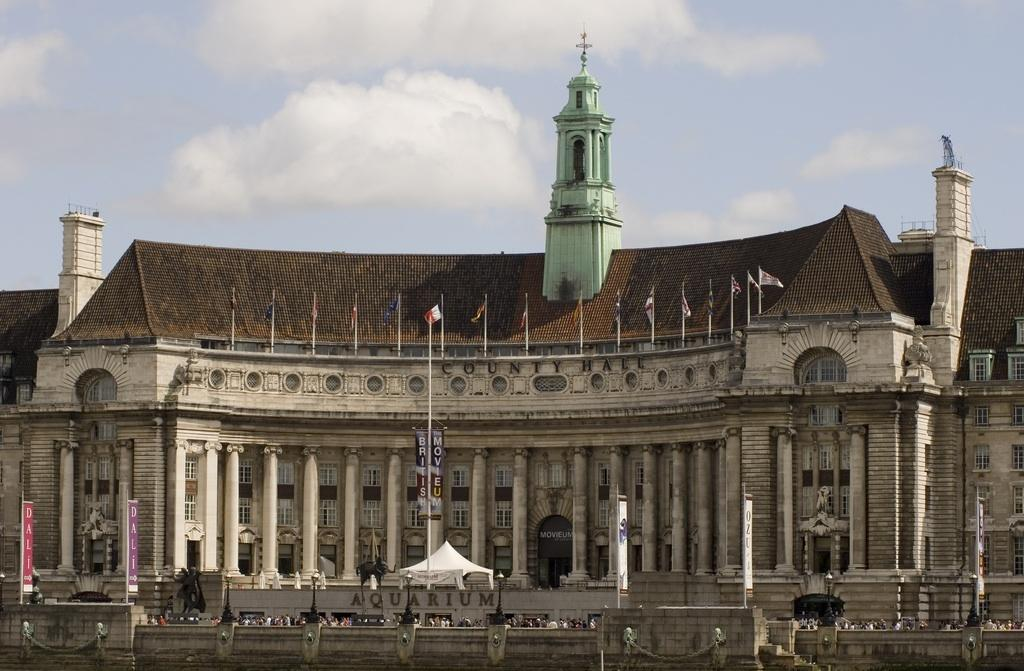What type of structure is visible in the image? There is a building in the image. What is located in front of the building? There is a tent and a hoarding board in front of the building. What else can be seen in front of the building? There are poles in front of the building. What is visible at the top of the image? The sky is visible at the top of the image. What type of jeans is the mist wearing in the image? There is no mist or jeans present in the image. 